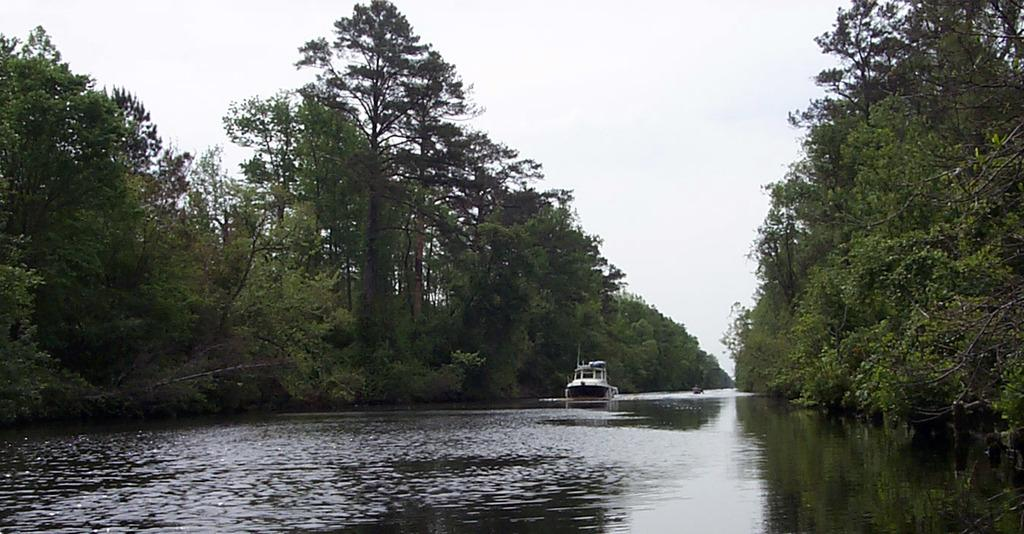What is the main subject of the image? There is a boat in the image. Where is the boat located? The boat is on a river. What can be seen in the surroundings of the river? There are green trees and plants surrounding the river. How would you describe the sky in the image? The sky is bright. How many cables are connected to the boat in the image? There are no cables connected to the boat in the image. 